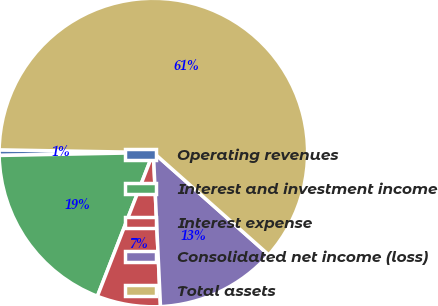Convert chart to OTSL. <chart><loc_0><loc_0><loc_500><loc_500><pie_chart><fcel>Operating revenues<fcel>Interest and investment income<fcel>Interest expense<fcel>Consolidated net income (loss)<fcel>Total assets<nl><fcel>0.58%<fcel>18.79%<fcel>6.65%<fcel>12.72%<fcel>61.28%<nl></chart> 